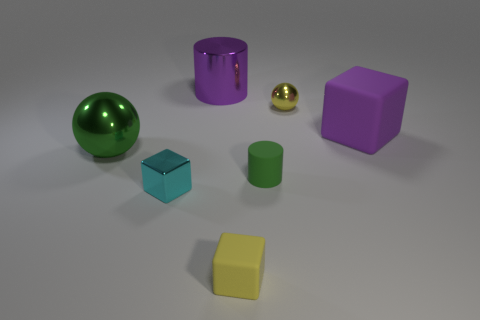What size is the purple object that is the same shape as the tiny yellow matte object?
Your answer should be compact. Large. What number of objects are both to the right of the green cylinder and behind the purple cube?
Offer a terse response. 1. There is a green metal thing; is it the same shape as the tiny yellow object behind the cyan object?
Make the answer very short. Yes. Are there more small yellow objects that are in front of the green matte cylinder than rubber balls?
Provide a short and direct response. Yes. Is the number of big metallic cylinders on the left side of the big green sphere less than the number of blue rubber blocks?
Keep it short and to the point. No. What number of things have the same color as the tiny matte cylinder?
Ensure brevity in your answer.  1. What is the cube that is both right of the cyan cube and to the left of the tiny yellow metallic object made of?
Keep it short and to the point. Rubber. There is a matte thing that is in front of the tiny green matte cylinder; is its color the same as the cylinder that is in front of the big metal cylinder?
Ensure brevity in your answer.  No. How many cyan things are either rubber blocks or small matte cubes?
Your answer should be very brief. 0. Are there fewer small green things that are left of the tiny ball than tiny yellow objects behind the metal cylinder?
Your response must be concise. No. 